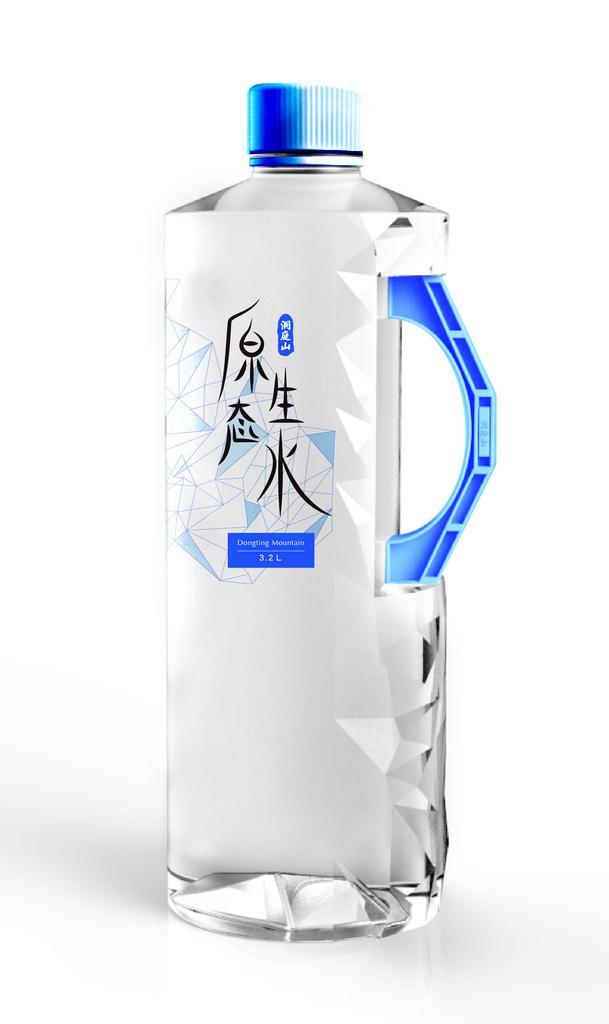Please provide a concise description of this image. This is a water bottle. 